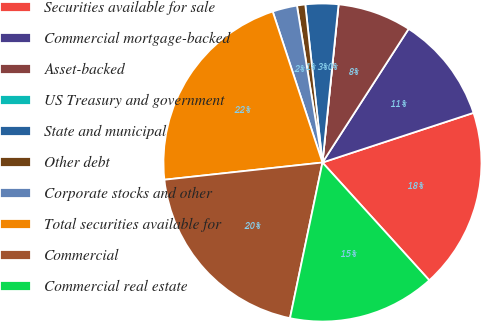Convert chart. <chart><loc_0><loc_0><loc_500><loc_500><pie_chart><fcel>Securities available for sale<fcel>Commercial mortgage-backed<fcel>Asset-backed<fcel>US Treasury and government<fcel>State and municipal<fcel>Other debt<fcel>Corporate stocks and other<fcel>Total securities available for<fcel>Commercial<fcel>Commercial real estate<nl><fcel>18.33%<fcel>10.83%<fcel>7.5%<fcel>0.0%<fcel>3.34%<fcel>0.84%<fcel>2.5%<fcel>21.66%<fcel>20.0%<fcel>15.0%<nl></chart> 